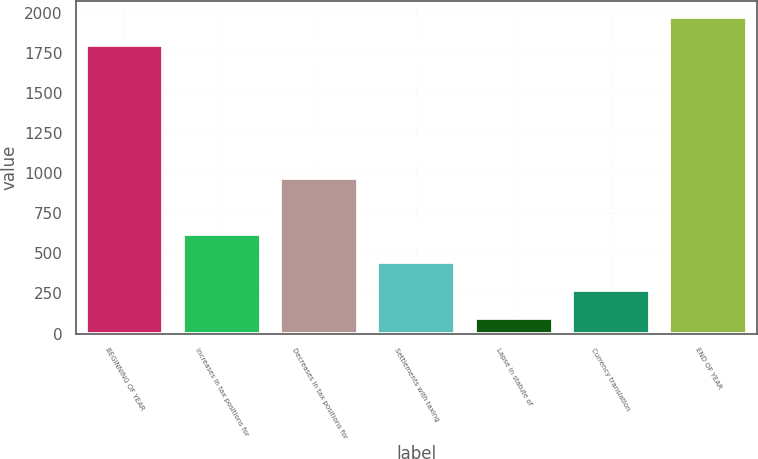Convert chart. <chart><loc_0><loc_0><loc_500><loc_500><bar_chart><fcel>BEGINNING OF YEAR<fcel>Increases in tax positions for<fcel>Decreases in tax positions for<fcel>Settlements with taxing<fcel>Lapse in statute of<fcel>Currency translation<fcel>END OF YEAR<nl><fcel>1797<fcel>620.2<fcel>971<fcel>444.8<fcel>94<fcel>269.4<fcel>1972.4<nl></chart> 